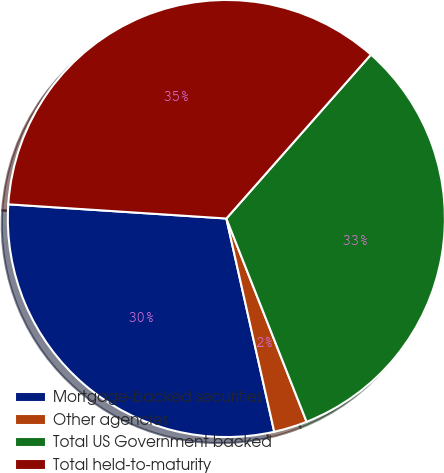<chart> <loc_0><loc_0><loc_500><loc_500><pie_chart><fcel>Mortgage-backed securities<fcel>Other agencies<fcel>Total US Government backed<fcel>Total held-to-maturity<nl><fcel>29.55%<fcel>2.47%<fcel>32.51%<fcel>35.47%<nl></chart> 